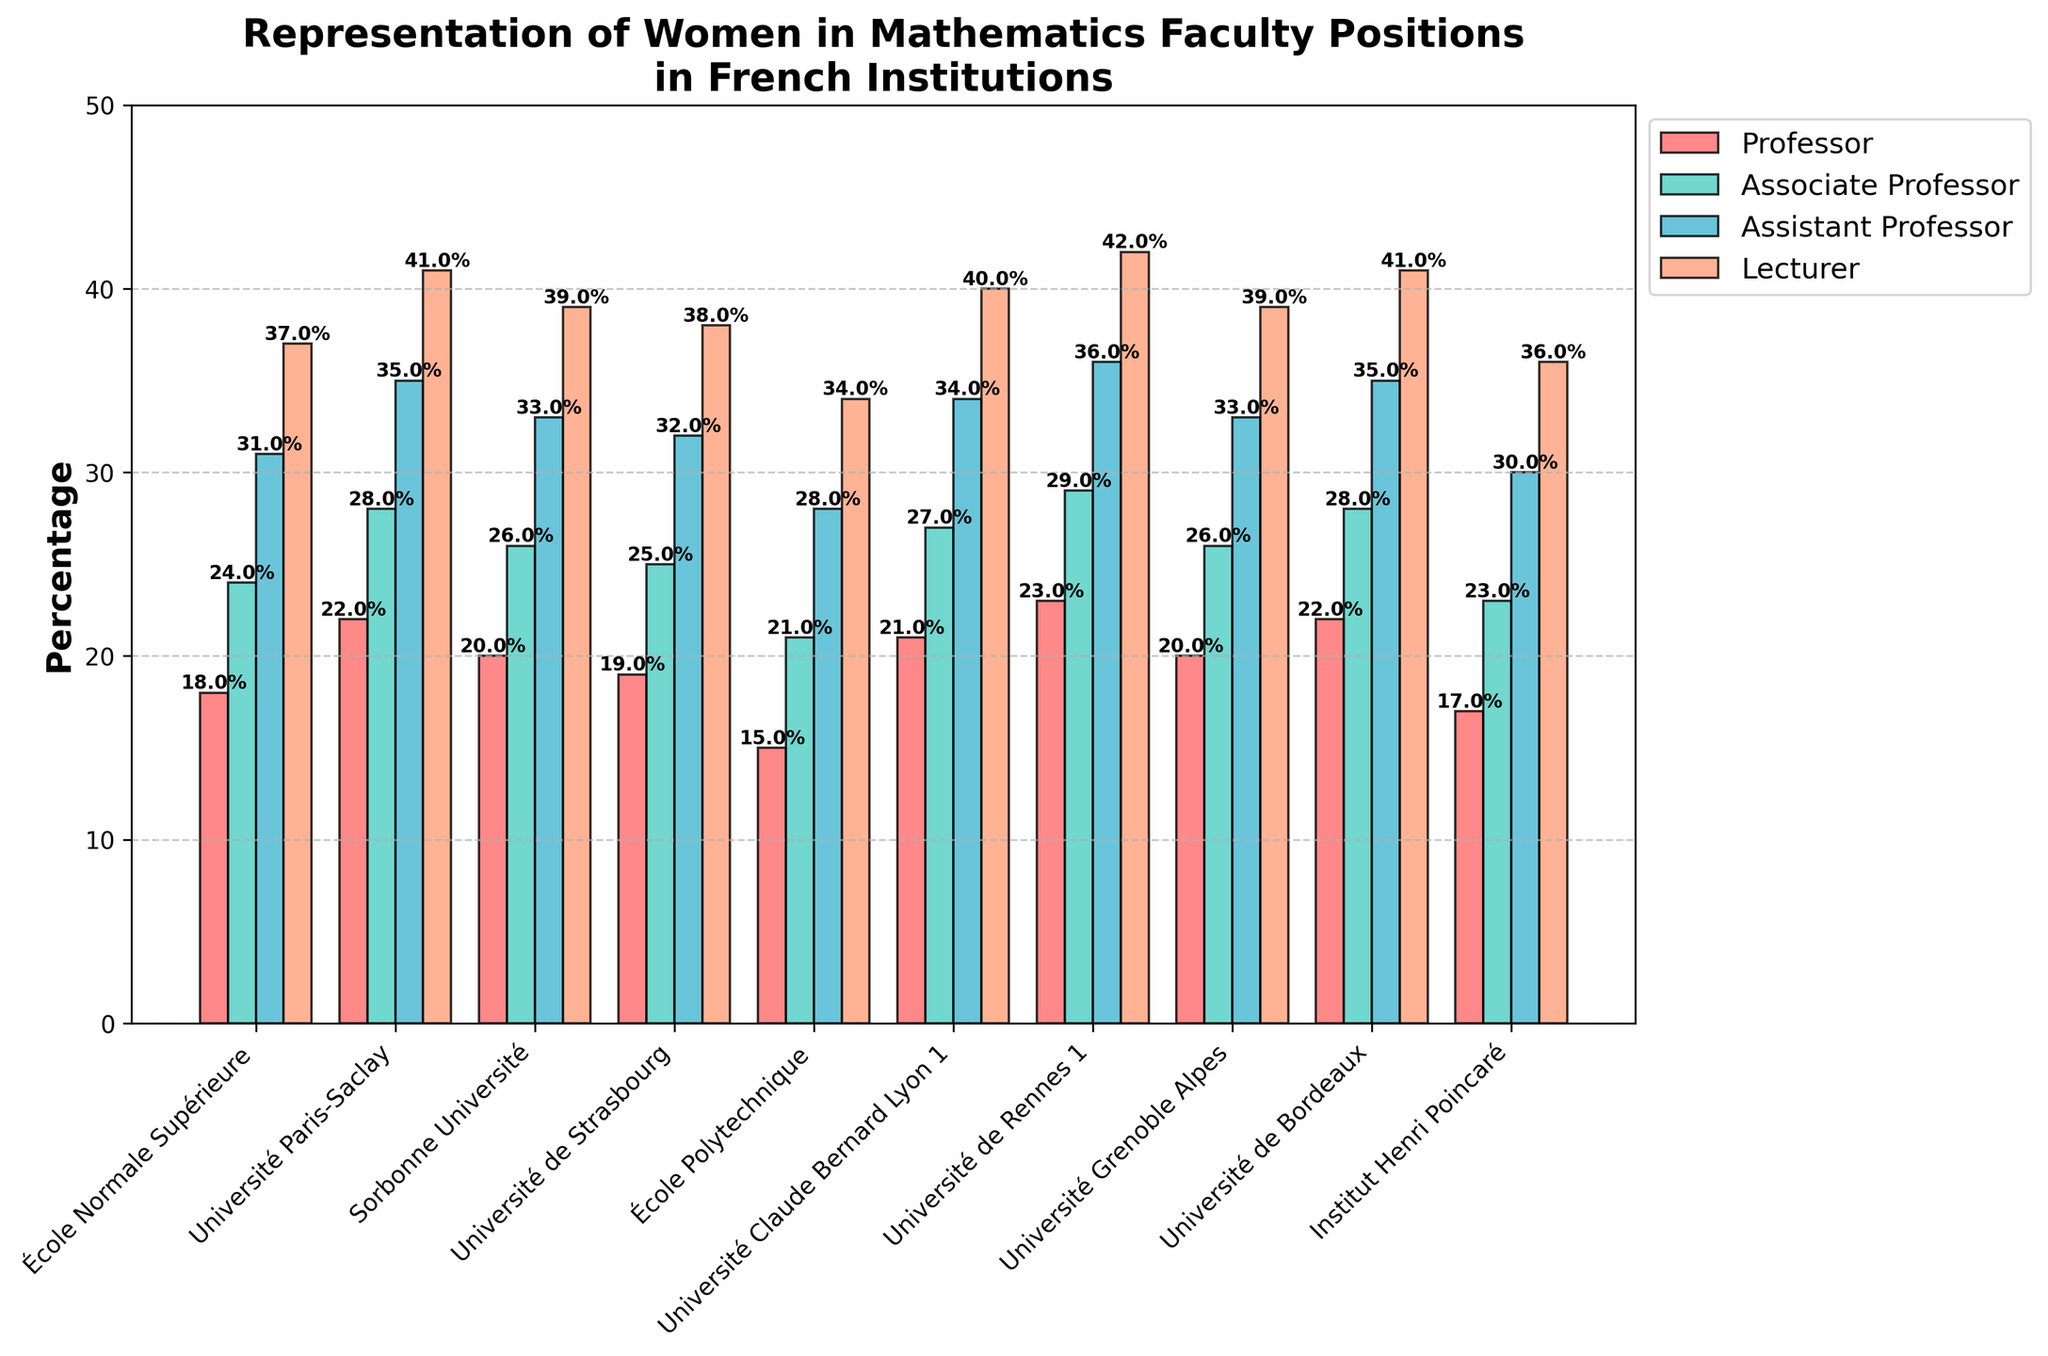What's the highest percentage of women lecturers in the institutions? Look at the heights of the bars for the position "Lecturer". Université de Rennes 1 has the highest percentage at 42%.
Answer: 42% Which institution has the lowest percentage of women professors? Find the shortest bar for the position "Professor". École Polytechnique has the lowest percentage at 15%.
Answer: 15% What's the difference in the percentage of women associate professors between Université Paris-Saclay and Sorbonne Université? Subtract Sorbonne Université's percentage (26%) from Université Paris-Saclay's percentage (28%). The difference is 2%.
Answer: 2% Which rank consistently shows the highest representation of women across all institutions? Compare the colors of bars for each rank visually. "Lecturer" consistently has the highest percentage across all institutions.
Answer: Lecturer What is the average percentage of women assistant professors in the listed institutions? Sum the percentages of women assistant professors for all institutions and divide by the number of institutions. Calculation: (31 + 35 + 33 + 32 + 28 + 34 + 36 + 33 + 35 + 30) / 10 = 32.7%.
Answer: 32.7% How does the percentage of women lecturers at École Normale Supérieure compare to Université Grenoble Alpes? Compare the bars for École Normale Supérieure (37%) to Université Grenoble Alpes (39%). Université Grenoble Alpes has a higher percentage.
Answer: Université Grenoble Alpes Which institution has the closest percentages of women professors and associate professors? For each institution, subtract the percentage of women professors from the percentage of women associate professors. The smallest difference is at Université de Rennes 1, with a difference of 6%.
Answer: Université de Rennes 1 How much higher is the percentage of women lecturers at Université de Bordeaux compared to École Polytechnique? Subtract the percentage at École Polytechnique (34%) from Université de Bordeaux (41%), which results in a difference of 7%.
Answer: 7% What's the sum of percentages of women in all four ranks at Institut Henri Poincaré? Add the percentages for each rank: 17% + 23% + 30% + 36% = 106%.
Answer: 106% Which two institutions have the same percentage of women in an academic rank? Observe the bars for each position. Université de Bordeaux and Université Paris-Saclay both have 35% of women assistant professors.
Answer: Université de Bordeaux and Université Paris-Saclay 